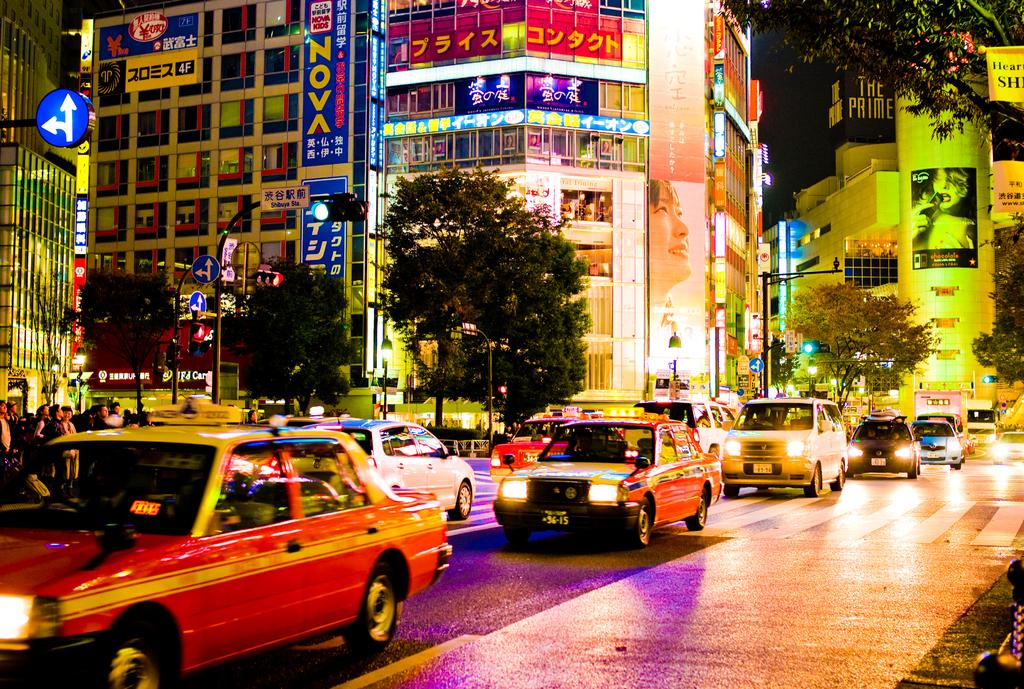<image>
Provide a brief description of the given image. A sign that says Nova is on the side of a building among many signs in a foreign language. 